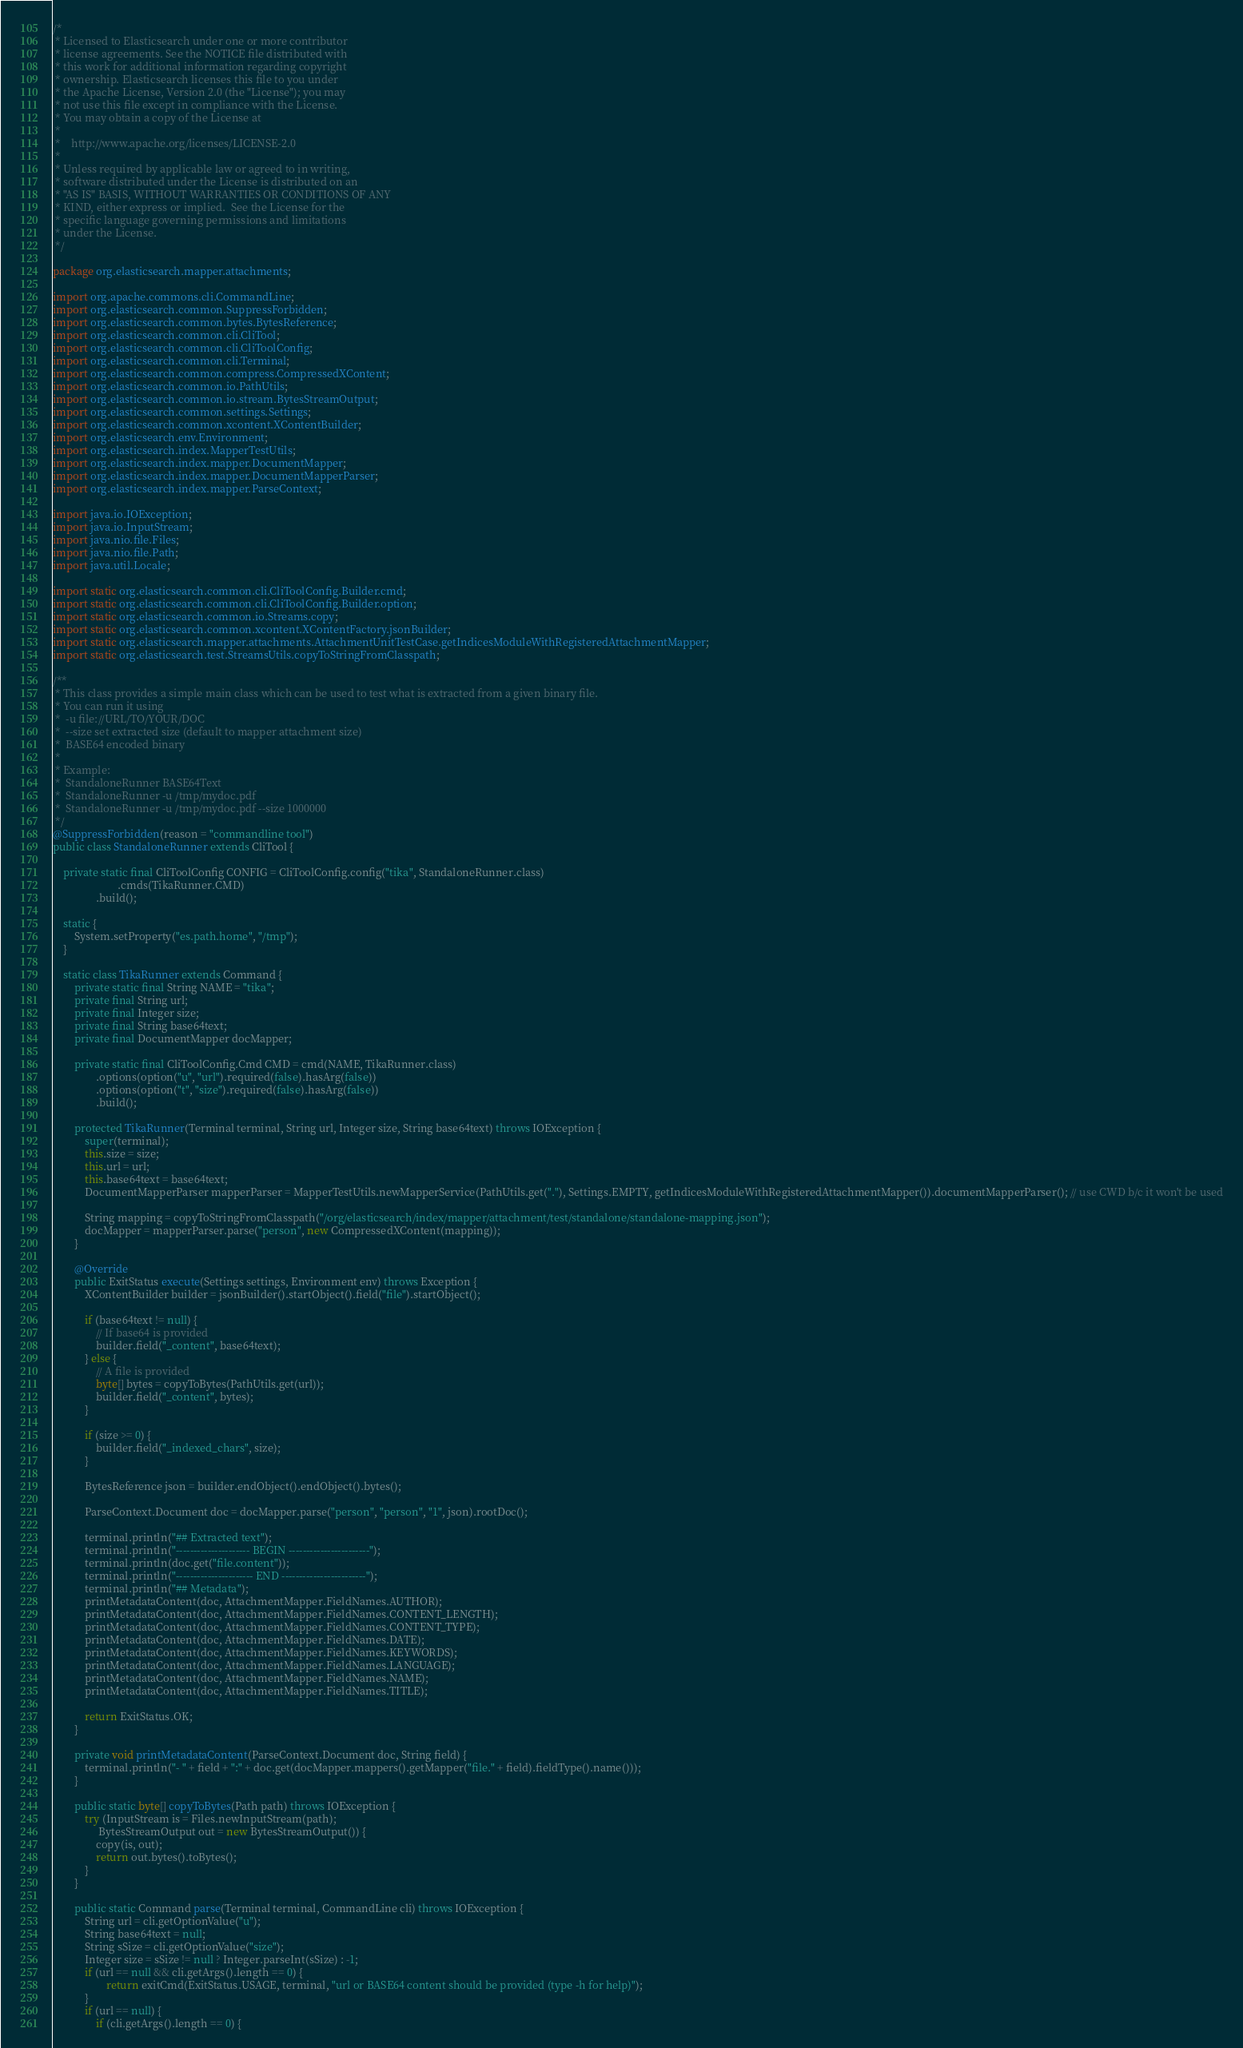Convert code to text. <code><loc_0><loc_0><loc_500><loc_500><_Java_>/*
 * Licensed to Elasticsearch under one or more contributor
 * license agreements. See the NOTICE file distributed with
 * this work for additional information regarding copyright
 * ownership. Elasticsearch licenses this file to you under
 * the Apache License, Version 2.0 (the "License"); you may
 * not use this file except in compliance with the License.
 * You may obtain a copy of the License at
 *
 *    http://www.apache.org/licenses/LICENSE-2.0
 *
 * Unless required by applicable law or agreed to in writing,
 * software distributed under the License is distributed on an
 * "AS IS" BASIS, WITHOUT WARRANTIES OR CONDITIONS OF ANY
 * KIND, either express or implied.  See the License for the
 * specific language governing permissions and limitations
 * under the License.
 */

package org.elasticsearch.mapper.attachments;

import org.apache.commons.cli.CommandLine;
import org.elasticsearch.common.SuppressForbidden;
import org.elasticsearch.common.bytes.BytesReference;
import org.elasticsearch.common.cli.CliTool;
import org.elasticsearch.common.cli.CliToolConfig;
import org.elasticsearch.common.cli.Terminal;
import org.elasticsearch.common.compress.CompressedXContent;
import org.elasticsearch.common.io.PathUtils;
import org.elasticsearch.common.io.stream.BytesStreamOutput;
import org.elasticsearch.common.settings.Settings;
import org.elasticsearch.common.xcontent.XContentBuilder;
import org.elasticsearch.env.Environment;
import org.elasticsearch.index.MapperTestUtils;
import org.elasticsearch.index.mapper.DocumentMapper;
import org.elasticsearch.index.mapper.DocumentMapperParser;
import org.elasticsearch.index.mapper.ParseContext;

import java.io.IOException;
import java.io.InputStream;
import java.nio.file.Files;
import java.nio.file.Path;
import java.util.Locale;

import static org.elasticsearch.common.cli.CliToolConfig.Builder.cmd;
import static org.elasticsearch.common.cli.CliToolConfig.Builder.option;
import static org.elasticsearch.common.io.Streams.copy;
import static org.elasticsearch.common.xcontent.XContentFactory.jsonBuilder;
import static org.elasticsearch.mapper.attachments.AttachmentUnitTestCase.getIndicesModuleWithRegisteredAttachmentMapper;
import static org.elasticsearch.test.StreamsUtils.copyToStringFromClasspath;

/**
 * This class provides a simple main class which can be used to test what is extracted from a given binary file.
 * You can run it using
 *  -u file://URL/TO/YOUR/DOC
 *  --size set extracted size (default to mapper attachment size)
 *  BASE64 encoded binary
 *
 * Example:
 *  StandaloneRunner BASE64Text
 *  StandaloneRunner -u /tmp/mydoc.pdf
 *  StandaloneRunner -u /tmp/mydoc.pdf --size 1000000
 */
@SuppressForbidden(reason = "commandline tool")
public class StandaloneRunner extends CliTool {

    private static final CliToolConfig CONFIG = CliToolConfig.config("tika", StandaloneRunner.class)
                        .cmds(TikaRunner.CMD)
                .build();

    static {
        System.setProperty("es.path.home", "/tmp");
    }

    static class TikaRunner extends Command {
        private static final String NAME = "tika";
        private final String url;
        private final Integer size;
        private final String base64text;
        private final DocumentMapper docMapper;

        private static final CliToolConfig.Cmd CMD = cmd(NAME, TikaRunner.class)
                .options(option("u", "url").required(false).hasArg(false))
                .options(option("t", "size").required(false).hasArg(false))
                .build();

        protected TikaRunner(Terminal terminal, String url, Integer size, String base64text) throws IOException {
            super(terminal);
            this.size = size;
            this.url = url;
            this.base64text = base64text;
            DocumentMapperParser mapperParser = MapperTestUtils.newMapperService(PathUtils.get("."), Settings.EMPTY, getIndicesModuleWithRegisteredAttachmentMapper()).documentMapperParser(); // use CWD b/c it won't be used

            String mapping = copyToStringFromClasspath("/org/elasticsearch/index/mapper/attachment/test/standalone/standalone-mapping.json");
            docMapper = mapperParser.parse("person", new CompressedXContent(mapping));
        }

        @Override
        public ExitStatus execute(Settings settings, Environment env) throws Exception {
            XContentBuilder builder = jsonBuilder().startObject().field("file").startObject();

            if (base64text != null) {
                // If base64 is provided
                builder.field("_content", base64text);
            } else {
                // A file is provided
                byte[] bytes = copyToBytes(PathUtils.get(url));
                builder.field("_content", bytes);
            }

            if (size >= 0) {
                builder.field("_indexed_chars", size);
            }

            BytesReference json = builder.endObject().endObject().bytes();

            ParseContext.Document doc = docMapper.parse("person", "person", "1", json).rootDoc();

            terminal.println("## Extracted text");
            terminal.println("--------------------- BEGIN -----------------------");
            terminal.println(doc.get("file.content"));
            terminal.println("---------------------- END ------------------------");
            terminal.println("## Metadata");
            printMetadataContent(doc, AttachmentMapper.FieldNames.AUTHOR);
            printMetadataContent(doc, AttachmentMapper.FieldNames.CONTENT_LENGTH);
            printMetadataContent(doc, AttachmentMapper.FieldNames.CONTENT_TYPE);
            printMetadataContent(doc, AttachmentMapper.FieldNames.DATE);
            printMetadataContent(doc, AttachmentMapper.FieldNames.KEYWORDS);
            printMetadataContent(doc, AttachmentMapper.FieldNames.LANGUAGE);
            printMetadataContent(doc, AttachmentMapper.FieldNames.NAME);
            printMetadataContent(doc, AttachmentMapper.FieldNames.TITLE);

            return ExitStatus.OK;
        }

        private void printMetadataContent(ParseContext.Document doc, String field) {
            terminal.println("- " + field + ":" + doc.get(docMapper.mappers().getMapper("file." + field).fieldType().name()));
        }

        public static byte[] copyToBytes(Path path) throws IOException {
            try (InputStream is = Files.newInputStream(path);
                 BytesStreamOutput out = new BytesStreamOutput()) {
                copy(is, out);
                return out.bytes().toBytes();
            }
        }

        public static Command parse(Terminal terminal, CommandLine cli) throws IOException {
            String url = cli.getOptionValue("u");
            String base64text = null;
            String sSize = cli.getOptionValue("size");
            Integer size = sSize != null ? Integer.parseInt(sSize) : -1;
            if (url == null && cli.getArgs().length == 0) {
                    return exitCmd(ExitStatus.USAGE, terminal, "url or BASE64 content should be provided (type -h for help)");
            }
            if (url == null) {
                if (cli.getArgs().length == 0) {</code> 